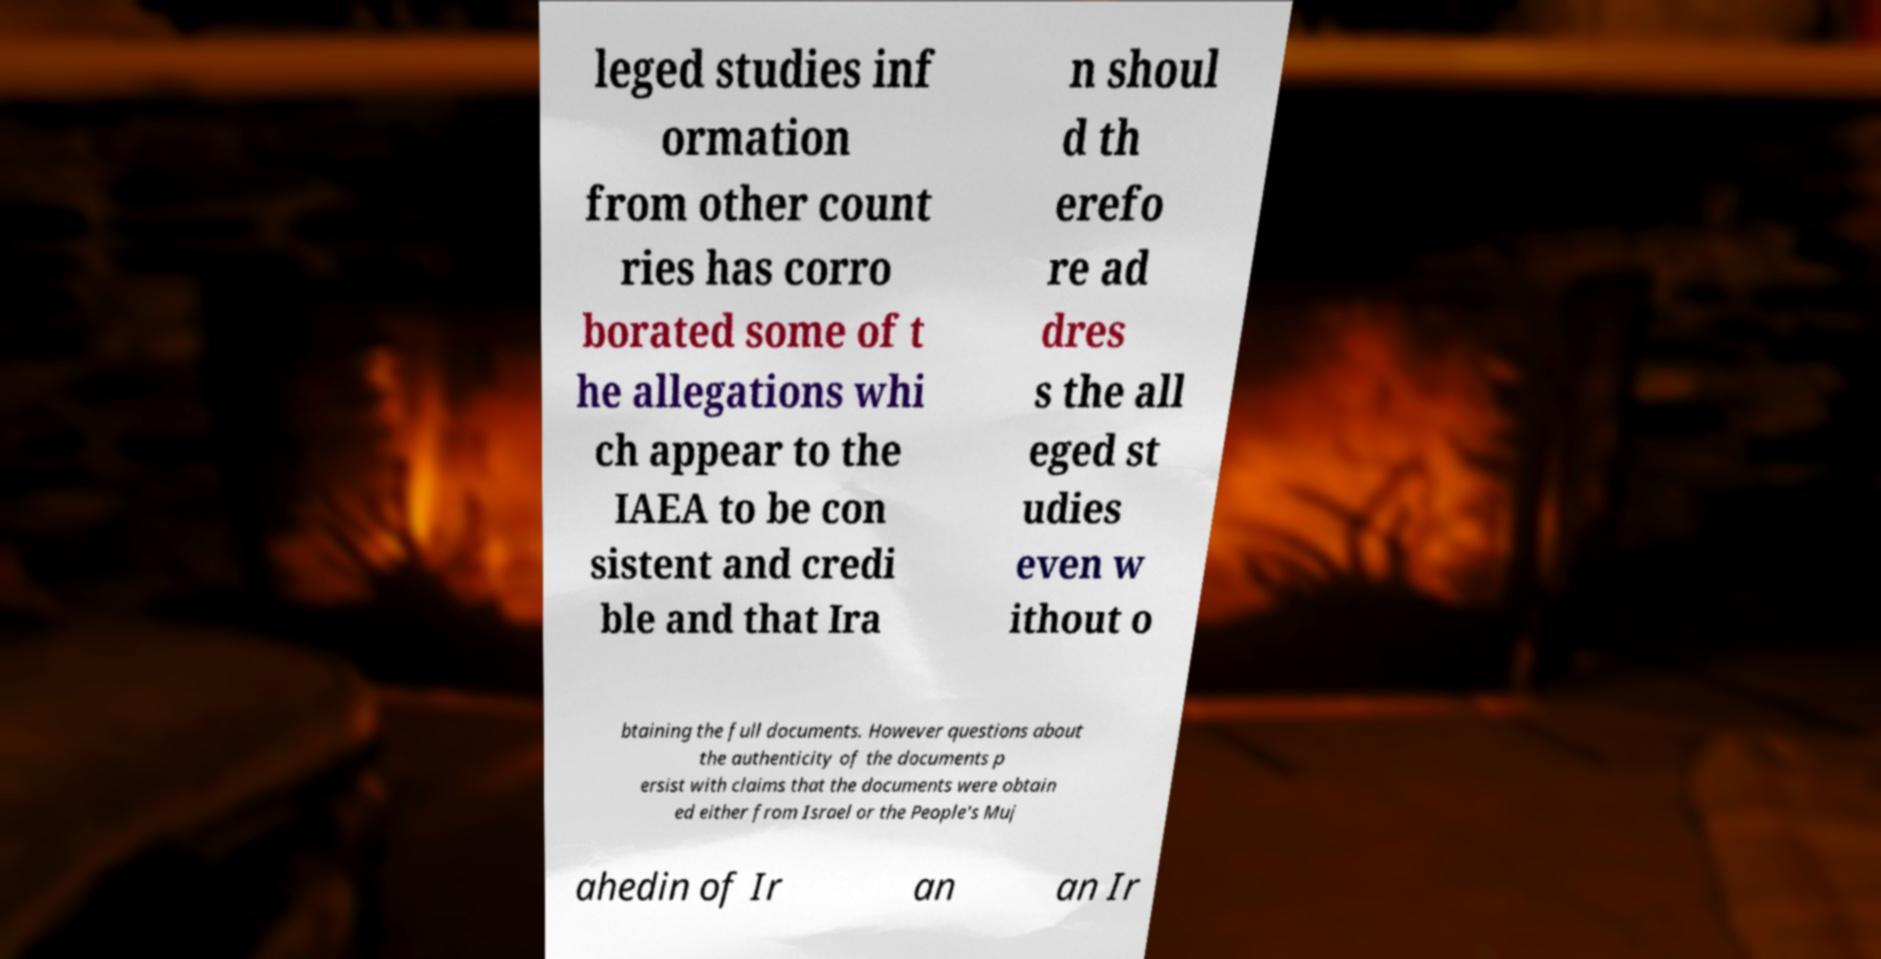For documentation purposes, I need the text within this image transcribed. Could you provide that? leged studies inf ormation from other count ries has corro borated some of t he allegations whi ch appear to the IAEA to be con sistent and credi ble and that Ira n shoul d th erefo re ad dres s the all eged st udies even w ithout o btaining the full documents. However questions about the authenticity of the documents p ersist with claims that the documents were obtain ed either from Israel or the People's Muj ahedin of Ir an an Ir 